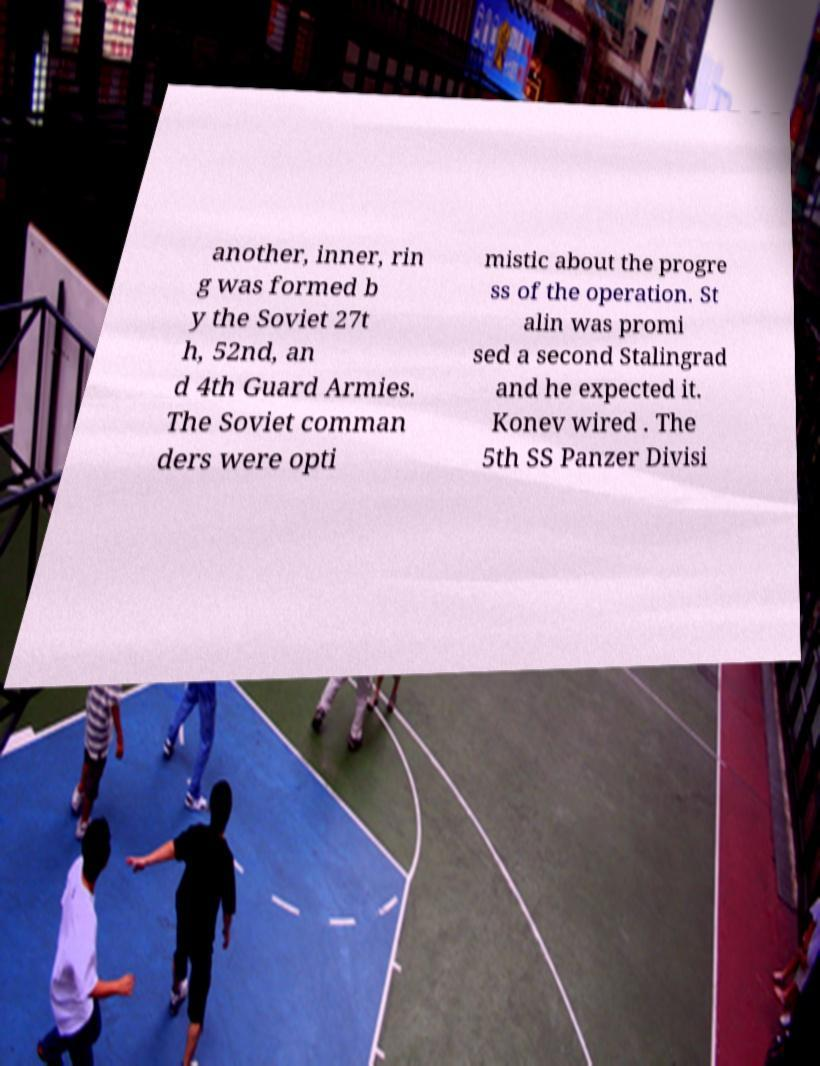I need the written content from this picture converted into text. Can you do that? another, inner, rin g was formed b y the Soviet 27t h, 52nd, an d 4th Guard Armies. The Soviet comman ders were opti mistic about the progre ss of the operation. St alin was promi sed a second Stalingrad and he expected it. Konev wired . The 5th SS Panzer Divisi 